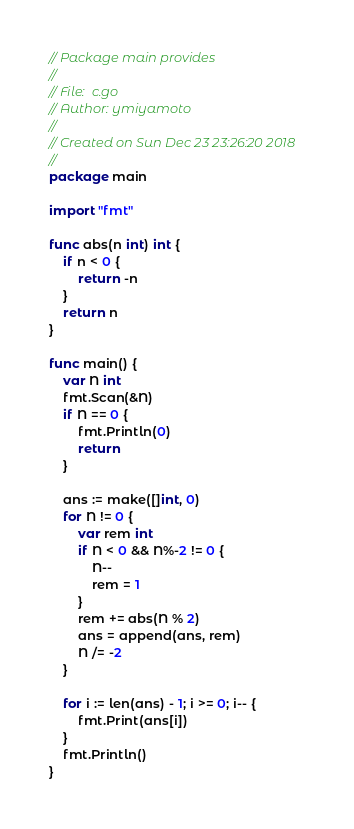Convert code to text. <code><loc_0><loc_0><loc_500><loc_500><_Go_>// Package main provides
//
// File:  c.go
// Author: ymiyamoto
//
// Created on Sun Dec 23 23:26:20 2018
//
package main

import "fmt"

func abs(n int) int {
	if n < 0 {
		return -n
	}
	return n
}

func main() {
	var N int
	fmt.Scan(&N)
	if N == 0 {
		fmt.Println(0)
		return
	}

	ans := make([]int, 0)
	for N != 0 {
		var rem int
		if N < 0 && N%-2 != 0 {
			N--
			rem = 1
		}
		rem += abs(N % 2)
		ans = append(ans, rem)
		N /= -2
	}

	for i := len(ans) - 1; i >= 0; i-- {
		fmt.Print(ans[i])
	}
	fmt.Println()
}
</code> 